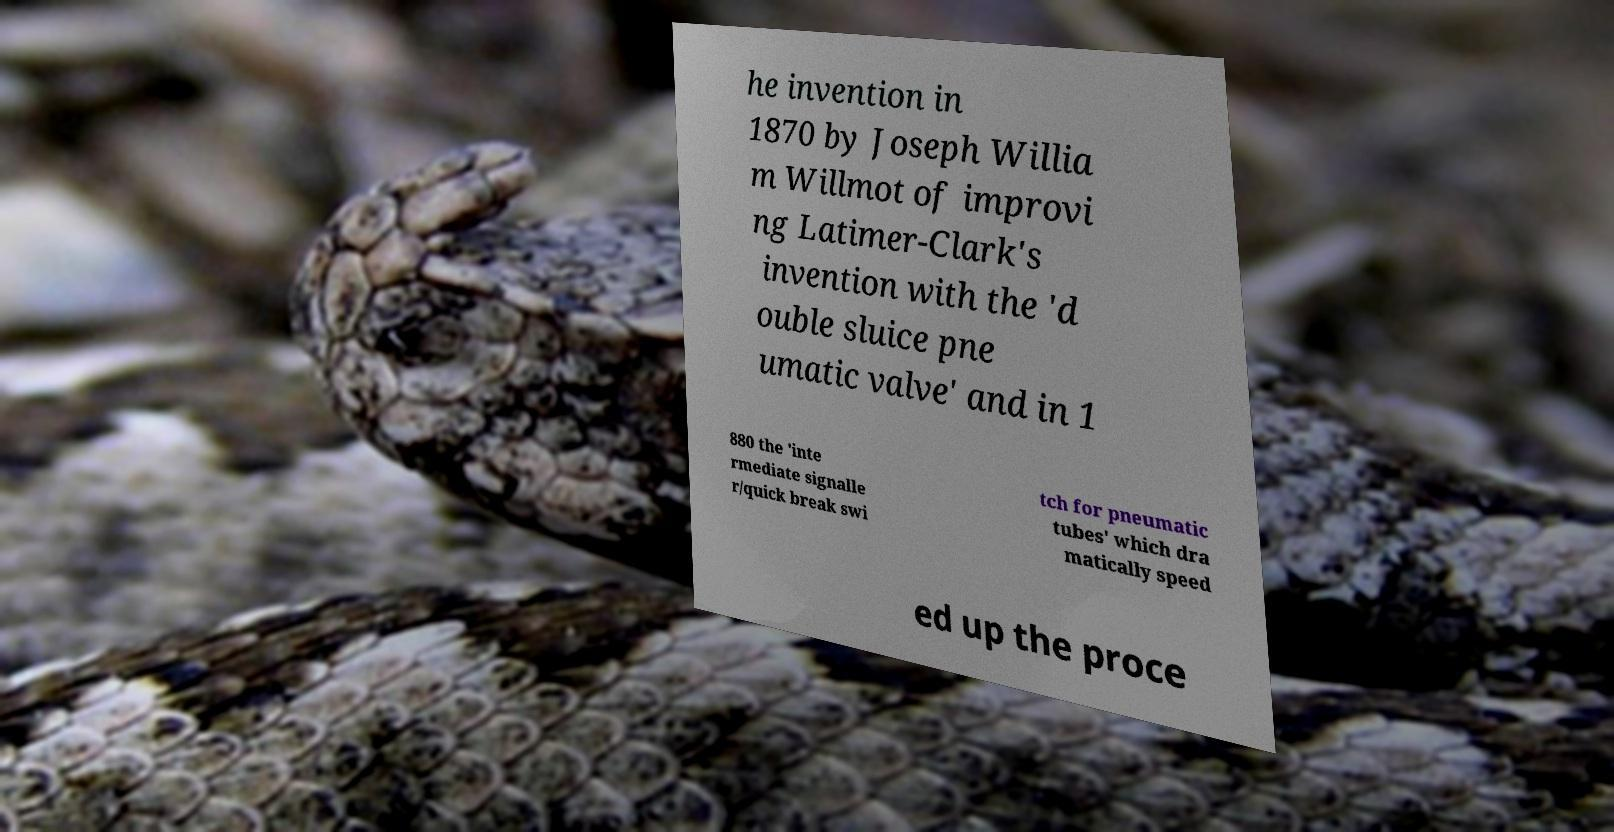Could you assist in decoding the text presented in this image and type it out clearly? he invention in 1870 by Joseph Willia m Willmot of improvi ng Latimer-Clark's invention with the 'd ouble sluice pne umatic valve' and in 1 880 the 'inte rmediate signalle r/quick break swi tch for pneumatic tubes' which dra matically speed ed up the proce 